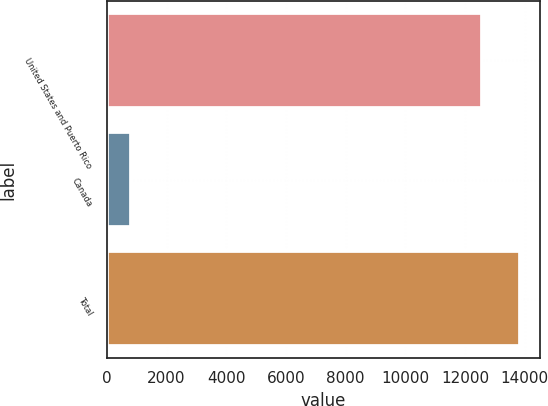Convert chart. <chart><loc_0><loc_0><loc_500><loc_500><bar_chart><fcel>United States and Puerto Rico<fcel>Canada<fcel>Total<nl><fcel>12578<fcel>800<fcel>13835.8<nl></chart> 